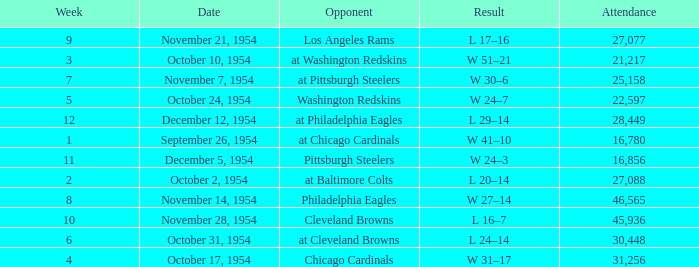How many weeks have october 31, 1954 as the date? 1.0. 